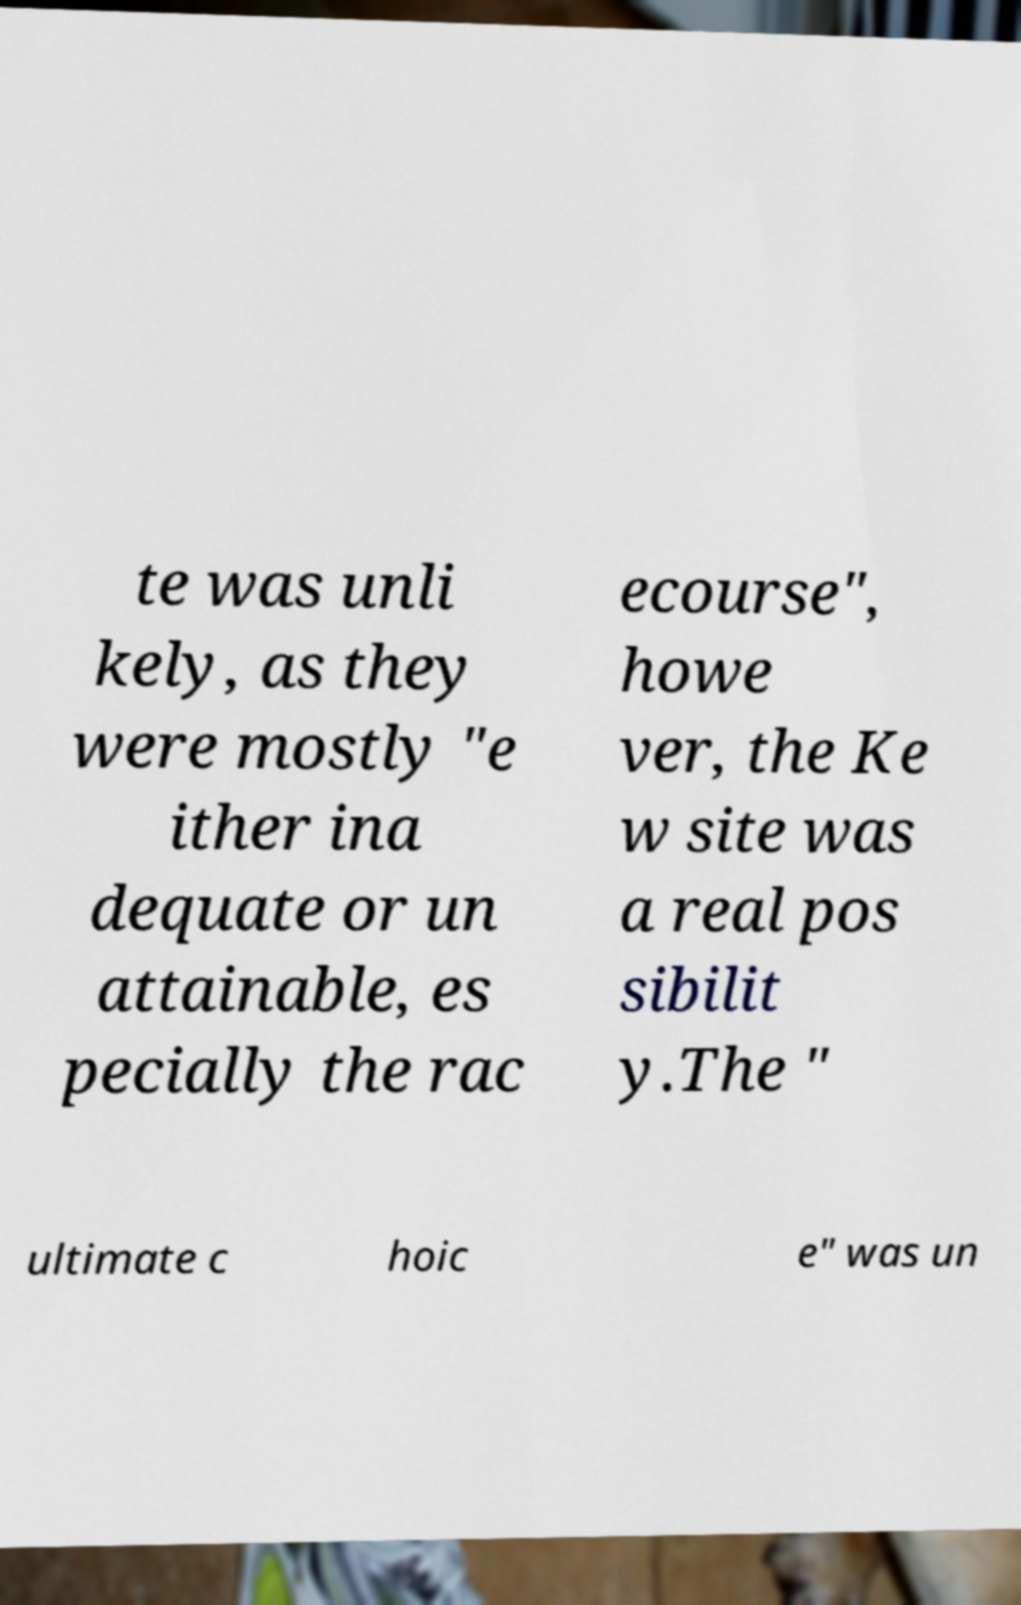There's text embedded in this image that I need extracted. Can you transcribe it verbatim? te was unli kely, as they were mostly "e ither ina dequate or un attainable, es pecially the rac ecourse", howe ver, the Ke w site was a real pos sibilit y.The " ultimate c hoic e" was un 